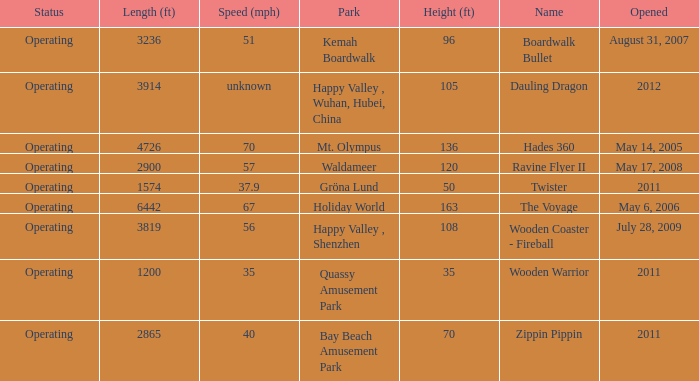How fast is the coaster that is 163 feet tall 67.0. 